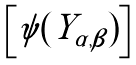<formula> <loc_0><loc_0><loc_500><loc_500>\begin{bmatrix} \psi ( Y _ { \alpha , \beta } ) \end{bmatrix}</formula> 